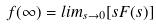Convert formula to latex. <formula><loc_0><loc_0><loc_500><loc_500>f ( \infty ) = l i m _ { s \rightarrow 0 } [ s F ( s ) ]</formula> 